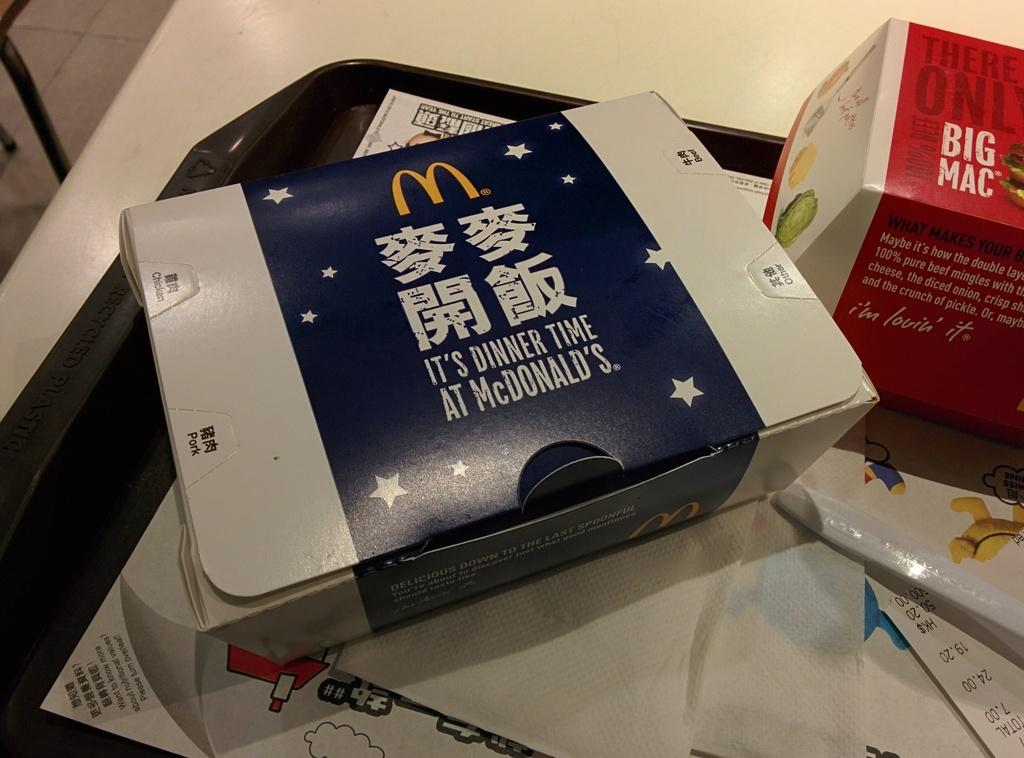<image>
Write a terse but informative summary of the picture. Several McDonald's boxes, including a Big Mac box, sit on a table. 